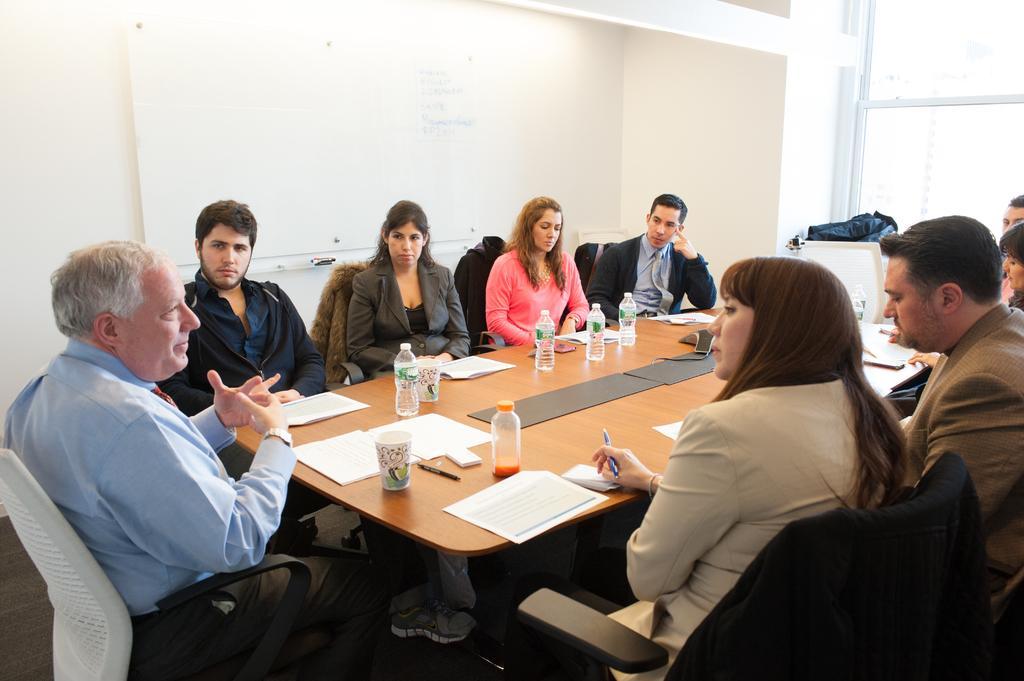Could you give a brief overview of what you see in this image? In the center of the image there is a table and we can see people sitting around the table. There are bottles, papers, cups and pens placed on the table. In the background we can see a board and a wall. On the right there is a window. 